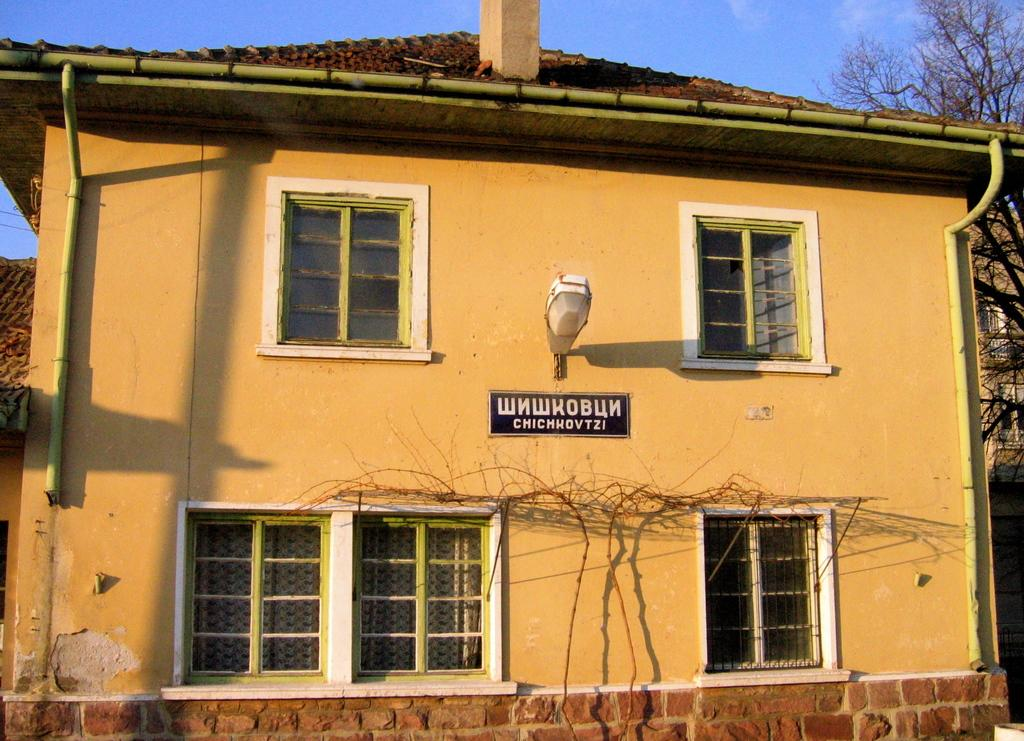<image>
Provide a brief description of the given image. A building has a sign on it that is a foreign language. 